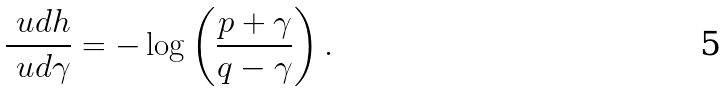<formula> <loc_0><loc_0><loc_500><loc_500>\frac { \ u d h } { \ u d \gamma } = - \log \left ( \frac { p + \gamma } { q - \gamma } \right ) .</formula> 